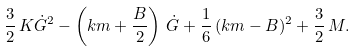Convert formula to latex. <formula><loc_0><loc_0><loc_500><loc_500>\frac { 3 } { 2 } \, K \dot { G } ^ { 2 } - \left ( k m + \frac { B } { 2 } \right ) \, \dot { G } + \frac { 1 } { 6 } \, ( k m - B ) ^ { 2 } + \frac { 3 } { 2 } \, M .</formula> 